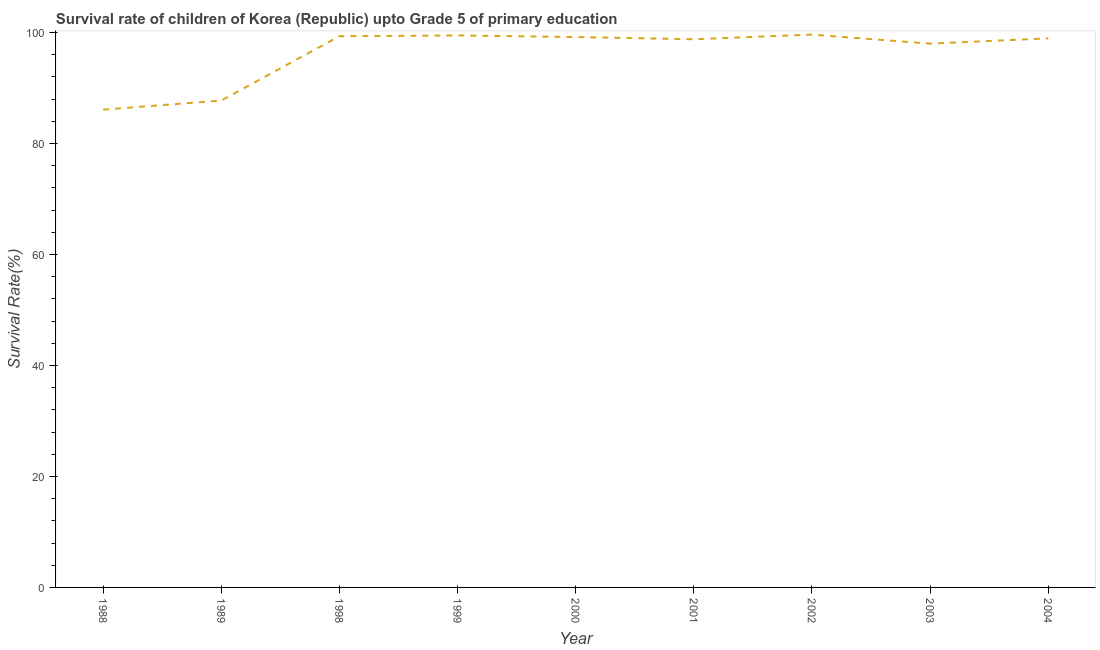What is the survival rate in 1988?
Your response must be concise. 86.09. Across all years, what is the maximum survival rate?
Offer a terse response. 99.61. Across all years, what is the minimum survival rate?
Provide a succinct answer. 86.09. In which year was the survival rate minimum?
Offer a terse response. 1988. What is the sum of the survival rate?
Your response must be concise. 867.02. What is the difference between the survival rate in 1999 and 2000?
Keep it short and to the point. 0.29. What is the average survival rate per year?
Provide a short and direct response. 96.34. What is the median survival rate?
Offer a very short reply. 98.93. What is the ratio of the survival rate in 2001 to that in 2003?
Ensure brevity in your answer.  1.01. Is the survival rate in 2001 less than that in 2004?
Keep it short and to the point. Yes. Is the difference between the survival rate in 1989 and 2002 greater than the difference between any two years?
Offer a terse response. No. What is the difference between the highest and the second highest survival rate?
Make the answer very short. 0.16. Is the sum of the survival rate in 2000 and 2003 greater than the maximum survival rate across all years?
Keep it short and to the point. Yes. What is the difference between the highest and the lowest survival rate?
Ensure brevity in your answer.  13.52. Does the survival rate monotonically increase over the years?
Ensure brevity in your answer.  No. Are the values on the major ticks of Y-axis written in scientific E-notation?
Offer a terse response. No. Does the graph contain any zero values?
Keep it short and to the point. No. Does the graph contain grids?
Ensure brevity in your answer.  No. What is the title of the graph?
Make the answer very short. Survival rate of children of Korea (Republic) upto Grade 5 of primary education. What is the label or title of the Y-axis?
Keep it short and to the point. Survival Rate(%). What is the Survival Rate(%) of 1988?
Ensure brevity in your answer.  86.09. What is the Survival Rate(%) of 1989?
Offer a terse response. 87.72. What is the Survival Rate(%) in 1998?
Keep it short and to the point. 99.31. What is the Survival Rate(%) of 1999?
Make the answer very short. 99.45. What is the Survival Rate(%) of 2000?
Provide a succinct answer. 99.17. What is the Survival Rate(%) of 2001?
Make the answer very short. 98.77. What is the Survival Rate(%) in 2002?
Offer a very short reply. 99.61. What is the Survival Rate(%) of 2003?
Your response must be concise. 97.98. What is the Survival Rate(%) in 2004?
Ensure brevity in your answer.  98.93. What is the difference between the Survival Rate(%) in 1988 and 1989?
Your response must be concise. -1.63. What is the difference between the Survival Rate(%) in 1988 and 1998?
Make the answer very short. -13.23. What is the difference between the Survival Rate(%) in 1988 and 1999?
Your answer should be compact. -13.37. What is the difference between the Survival Rate(%) in 1988 and 2000?
Provide a succinct answer. -13.08. What is the difference between the Survival Rate(%) in 1988 and 2001?
Your answer should be very brief. -12.68. What is the difference between the Survival Rate(%) in 1988 and 2002?
Keep it short and to the point. -13.52. What is the difference between the Survival Rate(%) in 1988 and 2003?
Keep it short and to the point. -11.89. What is the difference between the Survival Rate(%) in 1988 and 2004?
Your response must be concise. -12.85. What is the difference between the Survival Rate(%) in 1989 and 1998?
Ensure brevity in your answer.  -11.6. What is the difference between the Survival Rate(%) in 1989 and 1999?
Offer a very short reply. -11.73. What is the difference between the Survival Rate(%) in 1989 and 2000?
Provide a succinct answer. -11.45. What is the difference between the Survival Rate(%) in 1989 and 2001?
Offer a terse response. -11.05. What is the difference between the Survival Rate(%) in 1989 and 2002?
Your answer should be very brief. -11.89. What is the difference between the Survival Rate(%) in 1989 and 2003?
Offer a very short reply. -10.26. What is the difference between the Survival Rate(%) in 1989 and 2004?
Your response must be concise. -11.21. What is the difference between the Survival Rate(%) in 1998 and 1999?
Provide a succinct answer. -0.14. What is the difference between the Survival Rate(%) in 1998 and 2000?
Offer a very short reply. 0.15. What is the difference between the Survival Rate(%) in 1998 and 2001?
Provide a succinct answer. 0.55. What is the difference between the Survival Rate(%) in 1998 and 2002?
Provide a succinct answer. -0.29. What is the difference between the Survival Rate(%) in 1998 and 2003?
Your response must be concise. 1.34. What is the difference between the Survival Rate(%) in 1998 and 2004?
Ensure brevity in your answer.  0.38. What is the difference between the Survival Rate(%) in 1999 and 2000?
Provide a short and direct response. 0.29. What is the difference between the Survival Rate(%) in 1999 and 2001?
Keep it short and to the point. 0.68. What is the difference between the Survival Rate(%) in 1999 and 2002?
Offer a very short reply. -0.16. What is the difference between the Survival Rate(%) in 1999 and 2003?
Make the answer very short. 1.48. What is the difference between the Survival Rate(%) in 1999 and 2004?
Offer a very short reply. 0.52. What is the difference between the Survival Rate(%) in 2000 and 2001?
Provide a short and direct response. 0.4. What is the difference between the Survival Rate(%) in 2000 and 2002?
Make the answer very short. -0.44. What is the difference between the Survival Rate(%) in 2000 and 2003?
Your answer should be compact. 1.19. What is the difference between the Survival Rate(%) in 2000 and 2004?
Keep it short and to the point. 0.23. What is the difference between the Survival Rate(%) in 2001 and 2002?
Your answer should be very brief. -0.84. What is the difference between the Survival Rate(%) in 2001 and 2003?
Provide a succinct answer. 0.79. What is the difference between the Survival Rate(%) in 2001 and 2004?
Ensure brevity in your answer.  -0.16. What is the difference between the Survival Rate(%) in 2002 and 2003?
Your answer should be compact. 1.63. What is the difference between the Survival Rate(%) in 2002 and 2004?
Provide a short and direct response. 0.68. What is the difference between the Survival Rate(%) in 2003 and 2004?
Provide a succinct answer. -0.96. What is the ratio of the Survival Rate(%) in 1988 to that in 1989?
Provide a short and direct response. 0.98. What is the ratio of the Survival Rate(%) in 1988 to that in 1998?
Your answer should be very brief. 0.87. What is the ratio of the Survival Rate(%) in 1988 to that in 1999?
Your answer should be compact. 0.87. What is the ratio of the Survival Rate(%) in 1988 to that in 2000?
Your answer should be compact. 0.87. What is the ratio of the Survival Rate(%) in 1988 to that in 2001?
Your answer should be very brief. 0.87. What is the ratio of the Survival Rate(%) in 1988 to that in 2002?
Your response must be concise. 0.86. What is the ratio of the Survival Rate(%) in 1988 to that in 2003?
Provide a succinct answer. 0.88. What is the ratio of the Survival Rate(%) in 1988 to that in 2004?
Your answer should be very brief. 0.87. What is the ratio of the Survival Rate(%) in 1989 to that in 1998?
Your answer should be compact. 0.88. What is the ratio of the Survival Rate(%) in 1989 to that in 1999?
Your answer should be compact. 0.88. What is the ratio of the Survival Rate(%) in 1989 to that in 2000?
Provide a short and direct response. 0.89. What is the ratio of the Survival Rate(%) in 1989 to that in 2001?
Offer a very short reply. 0.89. What is the ratio of the Survival Rate(%) in 1989 to that in 2002?
Provide a short and direct response. 0.88. What is the ratio of the Survival Rate(%) in 1989 to that in 2003?
Make the answer very short. 0.9. What is the ratio of the Survival Rate(%) in 1989 to that in 2004?
Make the answer very short. 0.89. What is the ratio of the Survival Rate(%) in 1998 to that in 2003?
Your response must be concise. 1.01. What is the ratio of the Survival Rate(%) in 1999 to that in 2003?
Your answer should be compact. 1.01. What is the ratio of the Survival Rate(%) in 2000 to that in 2001?
Keep it short and to the point. 1. What is the ratio of the Survival Rate(%) in 2000 to that in 2002?
Make the answer very short. 1. What is the ratio of the Survival Rate(%) in 2000 to that in 2004?
Your answer should be compact. 1. What is the ratio of the Survival Rate(%) in 2001 to that in 2004?
Provide a short and direct response. 1. What is the ratio of the Survival Rate(%) in 2002 to that in 2003?
Provide a short and direct response. 1.02. What is the ratio of the Survival Rate(%) in 2002 to that in 2004?
Provide a short and direct response. 1.01. 